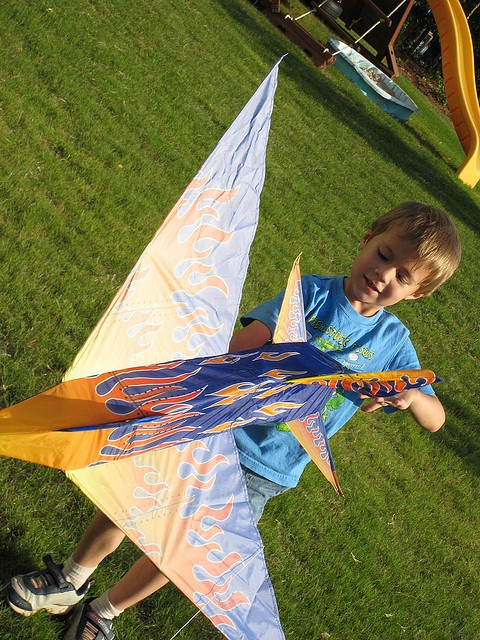Describe the objects in this image and their specific colors. I can see kite in darkgreen, lightgray, tan, darkgray, and navy tones and people in darkgreen, black, maroon, and lightblue tones in this image. 